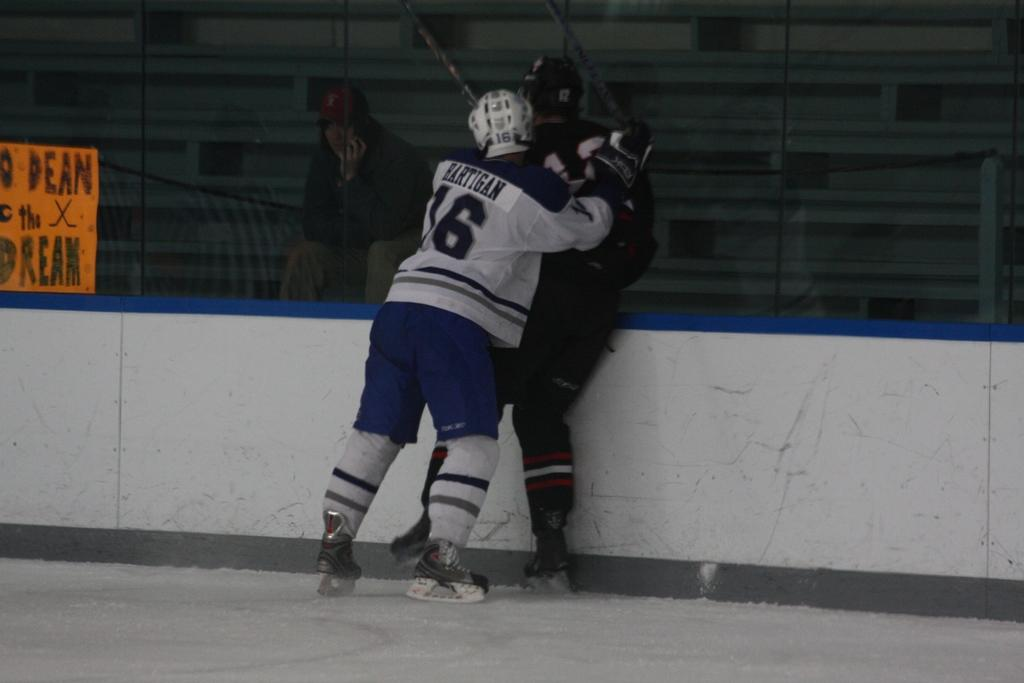What are the people in the image doing? The people in the image are standing on the floor. Are there any persons sitting in the image? Yes, there is a person sitting on a chair in the image. How many cattle can be seen grazing in the image? There are no cattle present in the image; it features persons standing and sitting. What type of ocean is visible in the background of the image? There is no ocean visible in the image; it is focused on the persons standing and sitting. 